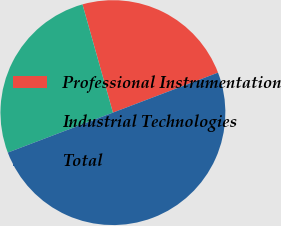Convert chart to OTSL. <chart><loc_0><loc_0><loc_500><loc_500><pie_chart><fcel>Professional Instrumentation<fcel>Industrial Technologies<fcel>Total<nl><fcel>23.58%<fcel>26.42%<fcel>50.0%<nl></chart> 